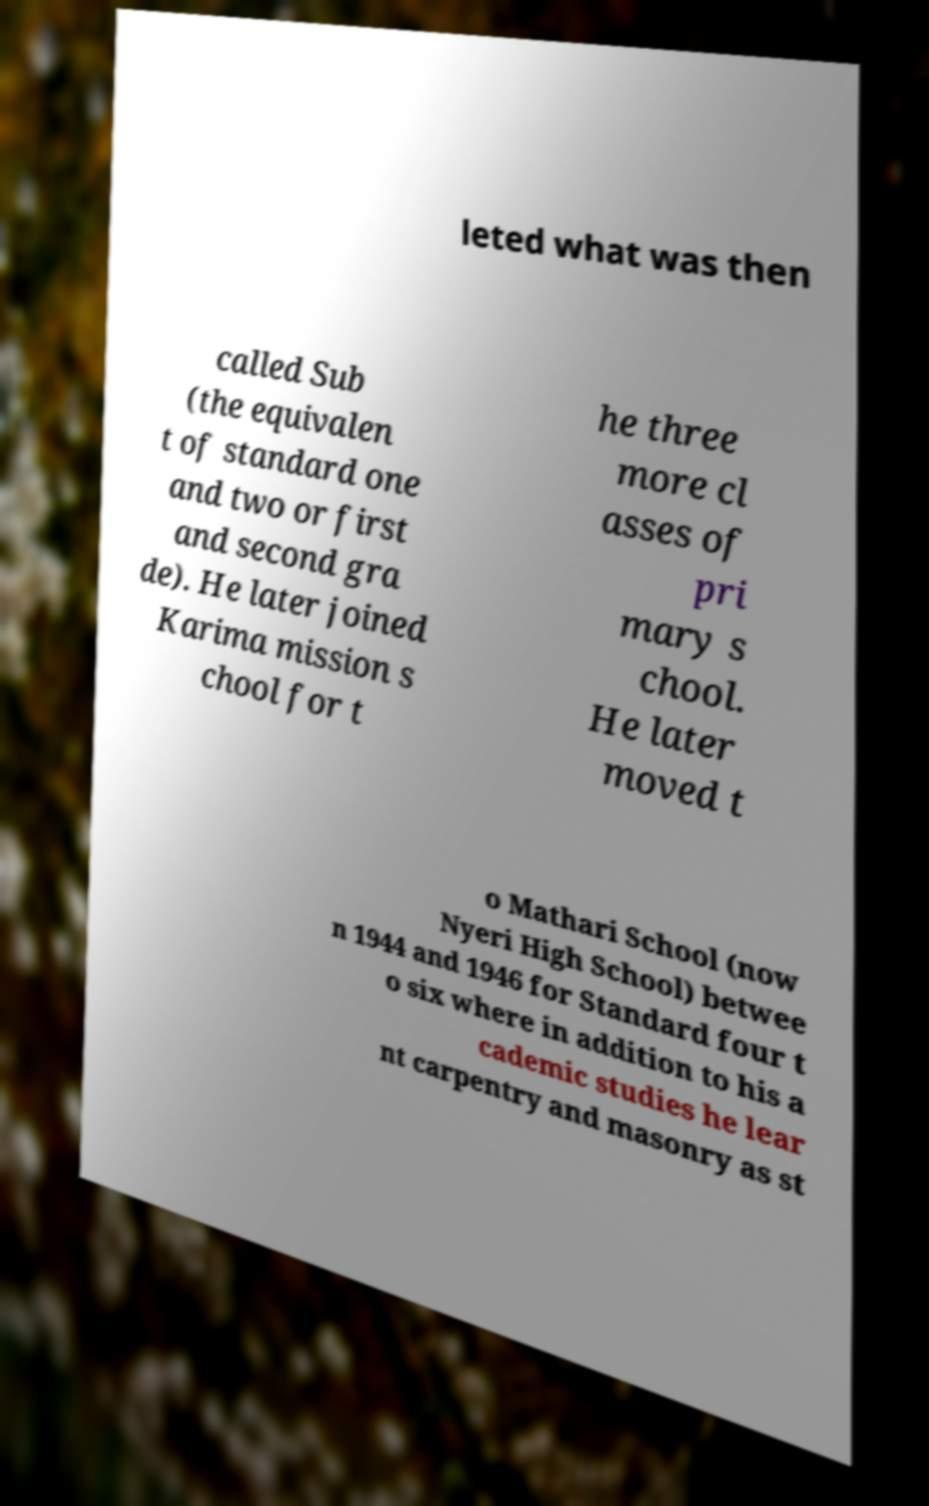Please identify and transcribe the text found in this image. leted what was then called Sub (the equivalen t of standard one and two or first and second gra de). He later joined Karima mission s chool for t he three more cl asses of pri mary s chool. He later moved t o Mathari School (now Nyeri High School) betwee n 1944 and 1946 for Standard four t o six where in addition to his a cademic studies he lear nt carpentry and masonry as st 